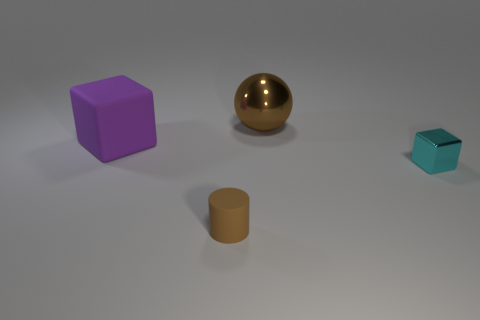What number of small objects have the same material as the big purple thing?
Provide a short and direct response. 1. There is a brown object that is right of the tiny rubber object; does it have the same size as the matte object that is behind the small matte cylinder?
Make the answer very short. Yes. What is the material of the brown thing in front of the brown thing behind the tiny cylinder?
Provide a short and direct response. Rubber. Is the number of brown balls on the left side of the large purple matte thing less than the number of tiny matte cylinders that are right of the brown rubber thing?
Keep it short and to the point. No. There is a tiny cylinder that is the same color as the metal ball; what is its material?
Make the answer very short. Rubber. Is there anything else that has the same shape as the big matte thing?
Your answer should be compact. Yes. There is a small object that is on the right side of the big metal sphere; what material is it?
Your answer should be very brief. Metal. Is there anything else that is the same size as the ball?
Offer a terse response. Yes. Are there any large purple things right of the big brown ball?
Make the answer very short. No. There is a cyan object; what shape is it?
Your answer should be compact. Cube. 